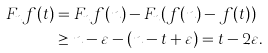Convert formula to latex. <formula><loc_0><loc_0><loc_500><loc_500>F _ { n } f ( t ) & = F _ { n } f ( n ) - F _ { n } ( f ( n ) - f ( t ) ) \\ & \geq n - \varepsilon - ( n - t + \varepsilon ) = t - 2 \varepsilon .</formula> 